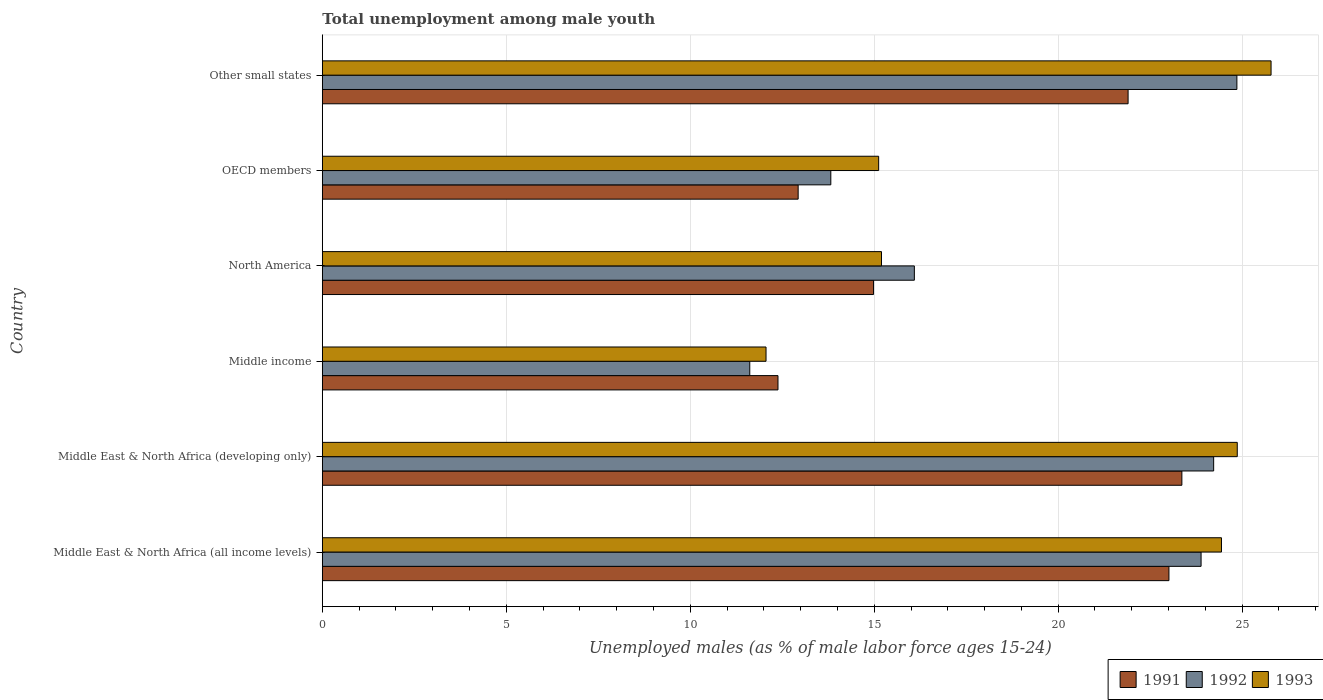Are the number of bars per tick equal to the number of legend labels?
Provide a short and direct response. Yes. Are the number of bars on each tick of the Y-axis equal?
Offer a terse response. Yes. How many bars are there on the 5th tick from the top?
Make the answer very short. 3. How many bars are there on the 1st tick from the bottom?
Provide a succinct answer. 3. What is the label of the 1st group of bars from the top?
Make the answer very short. Other small states. What is the percentage of unemployed males in in 1991 in Middle East & North Africa (developing only)?
Ensure brevity in your answer.  23.36. Across all countries, what is the maximum percentage of unemployed males in in 1993?
Keep it short and to the point. 25.79. Across all countries, what is the minimum percentage of unemployed males in in 1992?
Keep it short and to the point. 11.62. In which country was the percentage of unemployed males in in 1993 maximum?
Give a very brief answer. Other small states. In which country was the percentage of unemployed males in in 1993 minimum?
Give a very brief answer. Middle income. What is the total percentage of unemployed males in in 1991 in the graph?
Provide a short and direct response. 108.57. What is the difference between the percentage of unemployed males in in 1993 in Middle East & North Africa (all income levels) and that in North America?
Your answer should be very brief. 9.24. What is the difference between the percentage of unemployed males in in 1993 in North America and the percentage of unemployed males in in 1992 in Middle East & North Africa (all income levels)?
Keep it short and to the point. -8.69. What is the average percentage of unemployed males in in 1993 per country?
Provide a succinct answer. 19.58. What is the difference between the percentage of unemployed males in in 1991 and percentage of unemployed males in in 1992 in Middle income?
Provide a succinct answer. 0.77. In how many countries, is the percentage of unemployed males in in 1991 greater than 19 %?
Keep it short and to the point. 3. What is the ratio of the percentage of unemployed males in in 1993 in Middle income to that in OECD members?
Give a very brief answer. 0.8. Is the percentage of unemployed males in in 1993 in Middle East & North Africa (developing only) less than that in North America?
Give a very brief answer. No. What is the difference between the highest and the second highest percentage of unemployed males in in 1991?
Your answer should be very brief. 0.35. What is the difference between the highest and the lowest percentage of unemployed males in in 1993?
Provide a short and direct response. 13.73. In how many countries, is the percentage of unemployed males in in 1991 greater than the average percentage of unemployed males in in 1991 taken over all countries?
Ensure brevity in your answer.  3. What does the 2nd bar from the bottom in Other small states represents?
Ensure brevity in your answer.  1992. Are the values on the major ticks of X-axis written in scientific E-notation?
Make the answer very short. No. Does the graph contain grids?
Keep it short and to the point. Yes. Where does the legend appear in the graph?
Your response must be concise. Bottom right. What is the title of the graph?
Provide a short and direct response. Total unemployment among male youth. Does "2001" appear as one of the legend labels in the graph?
Offer a very short reply. No. What is the label or title of the X-axis?
Make the answer very short. Unemployed males (as % of male labor force ages 15-24). What is the label or title of the Y-axis?
Ensure brevity in your answer.  Country. What is the Unemployed males (as % of male labor force ages 15-24) in 1991 in Middle East & North Africa (all income levels)?
Give a very brief answer. 23.01. What is the Unemployed males (as % of male labor force ages 15-24) in 1992 in Middle East & North Africa (all income levels)?
Keep it short and to the point. 23.88. What is the Unemployed males (as % of male labor force ages 15-24) of 1993 in Middle East & North Africa (all income levels)?
Your response must be concise. 24.44. What is the Unemployed males (as % of male labor force ages 15-24) of 1991 in Middle East & North Africa (developing only)?
Provide a succinct answer. 23.36. What is the Unemployed males (as % of male labor force ages 15-24) of 1992 in Middle East & North Africa (developing only)?
Your response must be concise. 24.23. What is the Unemployed males (as % of male labor force ages 15-24) in 1993 in Middle East & North Africa (developing only)?
Your answer should be very brief. 24.87. What is the Unemployed males (as % of male labor force ages 15-24) in 1991 in Middle income?
Offer a terse response. 12.38. What is the Unemployed males (as % of male labor force ages 15-24) of 1992 in Middle income?
Offer a very short reply. 11.62. What is the Unemployed males (as % of male labor force ages 15-24) in 1993 in Middle income?
Your answer should be very brief. 12.06. What is the Unemployed males (as % of male labor force ages 15-24) of 1991 in North America?
Give a very brief answer. 14.98. What is the Unemployed males (as % of male labor force ages 15-24) in 1992 in North America?
Make the answer very short. 16.09. What is the Unemployed males (as % of male labor force ages 15-24) of 1993 in North America?
Make the answer very short. 15.2. What is the Unemployed males (as % of male labor force ages 15-24) in 1991 in OECD members?
Make the answer very short. 12.93. What is the Unemployed males (as % of male labor force ages 15-24) in 1992 in OECD members?
Your answer should be very brief. 13.82. What is the Unemployed males (as % of male labor force ages 15-24) in 1993 in OECD members?
Your answer should be very brief. 15.12. What is the Unemployed males (as % of male labor force ages 15-24) in 1991 in Other small states?
Ensure brevity in your answer.  21.9. What is the Unemployed males (as % of male labor force ages 15-24) of 1992 in Other small states?
Your response must be concise. 24.86. What is the Unemployed males (as % of male labor force ages 15-24) of 1993 in Other small states?
Offer a very short reply. 25.79. Across all countries, what is the maximum Unemployed males (as % of male labor force ages 15-24) of 1991?
Your response must be concise. 23.36. Across all countries, what is the maximum Unemployed males (as % of male labor force ages 15-24) of 1992?
Offer a very short reply. 24.86. Across all countries, what is the maximum Unemployed males (as % of male labor force ages 15-24) in 1993?
Keep it short and to the point. 25.79. Across all countries, what is the minimum Unemployed males (as % of male labor force ages 15-24) in 1991?
Make the answer very short. 12.38. Across all countries, what is the minimum Unemployed males (as % of male labor force ages 15-24) in 1992?
Your answer should be compact. 11.62. Across all countries, what is the minimum Unemployed males (as % of male labor force ages 15-24) of 1993?
Provide a short and direct response. 12.06. What is the total Unemployed males (as % of male labor force ages 15-24) in 1991 in the graph?
Make the answer very short. 108.57. What is the total Unemployed males (as % of male labor force ages 15-24) of 1992 in the graph?
Your response must be concise. 114.49. What is the total Unemployed males (as % of male labor force ages 15-24) of 1993 in the graph?
Ensure brevity in your answer.  117.47. What is the difference between the Unemployed males (as % of male labor force ages 15-24) of 1991 in Middle East & North Africa (all income levels) and that in Middle East & North Africa (developing only)?
Give a very brief answer. -0.35. What is the difference between the Unemployed males (as % of male labor force ages 15-24) in 1992 in Middle East & North Africa (all income levels) and that in Middle East & North Africa (developing only)?
Provide a succinct answer. -0.34. What is the difference between the Unemployed males (as % of male labor force ages 15-24) in 1993 in Middle East & North Africa (all income levels) and that in Middle East & North Africa (developing only)?
Ensure brevity in your answer.  -0.43. What is the difference between the Unemployed males (as % of male labor force ages 15-24) of 1991 in Middle East & North Africa (all income levels) and that in Middle income?
Give a very brief answer. 10.63. What is the difference between the Unemployed males (as % of male labor force ages 15-24) in 1992 in Middle East & North Africa (all income levels) and that in Middle income?
Provide a succinct answer. 12.27. What is the difference between the Unemployed males (as % of male labor force ages 15-24) in 1993 in Middle East & North Africa (all income levels) and that in Middle income?
Make the answer very short. 12.38. What is the difference between the Unemployed males (as % of male labor force ages 15-24) in 1991 in Middle East & North Africa (all income levels) and that in North America?
Provide a short and direct response. 8.03. What is the difference between the Unemployed males (as % of male labor force ages 15-24) of 1992 in Middle East & North Africa (all income levels) and that in North America?
Offer a terse response. 7.79. What is the difference between the Unemployed males (as % of male labor force ages 15-24) of 1993 in Middle East & North Africa (all income levels) and that in North America?
Provide a succinct answer. 9.24. What is the difference between the Unemployed males (as % of male labor force ages 15-24) in 1991 in Middle East & North Africa (all income levels) and that in OECD members?
Keep it short and to the point. 10.08. What is the difference between the Unemployed males (as % of male labor force ages 15-24) of 1992 in Middle East & North Africa (all income levels) and that in OECD members?
Your response must be concise. 10.06. What is the difference between the Unemployed males (as % of male labor force ages 15-24) of 1993 in Middle East & North Africa (all income levels) and that in OECD members?
Your response must be concise. 9.32. What is the difference between the Unemployed males (as % of male labor force ages 15-24) in 1991 in Middle East & North Africa (all income levels) and that in Other small states?
Your response must be concise. 1.11. What is the difference between the Unemployed males (as % of male labor force ages 15-24) in 1992 in Middle East & North Africa (all income levels) and that in Other small states?
Provide a short and direct response. -0.97. What is the difference between the Unemployed males (as % of male labor force ages 15-24) in 1993 in Middle East & North Africa (all income levels) and that in Other small states?
Ensure brevity in your answer.  -1.35. What is the difference between the Unemployed males (as % of male labor force ages 15-24) of 1991 in Middle East & North Africa (developing only) and that in Middle income?
Your answer should be very brief. 10.98. What is the difference between the Unemployed males (as % of male labor force ages 15-24) in 1992 in Middle East & North Africa (developing only) and that in Middle income?
Your answer should be compact. 12.61. What is the difference between the Unemployed males (as % of male labor force ages 15-24) in 1993 in Middle East & North Africa (developing only) and that in Middle income?
Ensure brevity in your answer.  12.81. What is the difference between the Unemployed males (as % of male labor force ages 15-24) of 1991 in Middle East & North Africa (developing only) and that in North America?
Your answer should be compact. 8.38. What is the difference between the Unemployed males (as % of male labor force ages 15-24) in 1992 in Middle East & North Africa (developing only) and that in North America?
Your response must be concise. 8.13. What is the difference between the Unemployed males (as % of male labor force ages 15-24) of 1993 in Middle East & North Africa (developing only) and that in North America?
Your answer should be compact. 9.67. What is the difference between the Unemployed males (as % of male labor force ages 15-24) of 1991 in Middle East & North Africa (developing only) and that in OECD members?
Your answer should be compact. 10.43. What is the difference between the Unemployed males (as % of male labor force ages 15-24) of 1992 in Middle East & North Africa (developing only) and that in OECD members?
Offer a very short reply. 10.41. What is the difference between the Unemployed males (as % of male labor force ages 15-24) in 1993 in Middle East & North Africa (developing only) and that in OECD members?
Offer a terse response. 9.75. What is the difference between the Unemployed males (as % of male labor force ages 15-24) in 1991 in Middle East & North Africa (developing only) and that in Other small states?
Offer a terse response. 1.46. What is the difference between the Unemployed males (as % of male labor force ages 15-24) in 1992 in Middle East & North Africa (developing only) and that in Other small states?
Your response must be concise. -0.63. What is the difference between the Unemployed males (as % of male labor force ages 15-24) of 1993 in Middle East & North Africa (developing only) and that in Other small states?
Keep it short and to the point. -0.92. What is the difference between the Unemployed males (as % of male labor force ages 15-24) of 1991 in Middle income and that in North America?
Provide a short and direct response. -2.6. What is the difference between the Unemployed males (as % of male labor force ages 15-24) in 1992 in Middle income and that in North America?
Ensure brevity in your answer.  -4.47. What is the difference between the Unemployed males (as % of male labor force ages 15-24) in 1993 in Middle income and that in North America?
Make the answer very short. -3.14. What is the difference between the Unemployed males (as % of male labor force ages 15-24) in 1991 in Middle income and that in OECD members?
Offer a very short reply. -0.55. What is the difference between the Unemployed males (as % of male labor force ages 15-24) in 1992 in Middle income and that in OECD members?
Give a very brief answer. -2.2. What is the difference between the Unemployed males (as % of male labor force ages 15-24) in 1993 in Middle income and that in OECD members?
Offer a very short reply. -3.06. What is the difference between the Unemployed males (as % of male labor force ages 15-24) in 1991 in Middle income and that in Other small states?
Your answer should be very brief. -9.52. What is the difference between the Unemployed males (as % of male labor force ages 15-24) in 1992 in Middle income and that in Other small states?
Provide a succinct answer. -13.24. What is the difference between the Unemployed males (as % of male labor force ages 15-24) of 1993 in Middle income and that in Other small states?
Offer a very short reply. -13.73. What is the difference between the Unemployed males (as % of male labor force ages 15-24) in 1991 in North America and that in OECD members?
Provide a succinct answer. 2.05. What is the difference between the Unemployed males (as % of male labor force ages 15-24) of 1992 in North America and that in OECD members?
Make the answer very short. 2.27. What is the difference between the Unemployed males (as % of male labor force ages 15-24) in 1993 in North America and that in OECD members?
Provide a short and direct response. 0.08. What is the difference between the Unemployed males (as % of male labor force ages 15-24) of 1991 in North America and that in Other small states?
Give a very brief answer. -6.92. What is the difference between the Unemployed males (as % of male labor force ages 15-24) in 1992 in North America and that in Other small states?
Your answer should be very brief. -8.77. What is the difference between the Unemployed males (as % of male labor force ages 15-24) of 1993 in North America and that in Other small states?
Offer a terse response. -10.59. What is the difference between the Unemployed males (as % of male labor force ages 15-24) of 1991 in OECD members and that in Other small states?
Your answer should be very brief. -8.97. What is the difference between the Unemployed males (as % of male labor force ages 15-24) in 1992 in OECD members and that in Other small states?
Your answer should be compact. -11.04. What is the difference between the Unemployed males (as % of male labor force ages 15-24) in 1993 in OECD members and that in Other small states?
Your response must be concise. -10.66. What is the difference between the Unemployed males (as % of male labor force ages 15-24) in 1991 in Middle East & North Africa (all income levels) and the Unemployed males (as % of male labor force ages 15-24) in 1992 in Middle East & North Africa (developing only)?
Your answer should be very brief. -1.22. What is the difference between the Unemployed males (as % of male labor force ages 15-24) in 1991 in Middle East & North Africa (all income levels) and the Unemployed males (as % of male labor force ages 15-24) in 1993 in Middle East & North Africa (developing only)?
Give a very brief answer. -1.86. What is the difference between the Unemployed males (as % of male labor force ages 15-24) in 1992 in Middle East & North Africa (all income levels) and the Unemployed males (as % of male labor force ages 15-24) in 1993 in Middle East & North Africa (developing only)?
Ensure brevity in your answer.  -0.98. What is the difference between the Unemployed males (as % of male labor force ages 15-24) of 1991 in Middle East & North Africa (all income levels) and the Unemployed males (as % of male labor force ages 15-24) of 1992 in Middle income?
Provide a succinct answer. 11.39. What is the difference between the Unemployed males (as % of male labor force ages 15-24) of 1991 in Middle East & North Africa (all income levels) and the Unemployed males (as % of male labor force ages 15-24) of 1993 in Middle income?
Your response must be concise. 10.95. What is the difference between the Unemployed males (as % of male labor force ages 15-24) in 1992 in Middle East & North Africa (all income levels) and the Unemployed males (as % of male labor force ages 15-24) in 1993 in Middle income?
Your response must be concise. 11.82. What is the difference between the Unemployed males (as % of male labor force ages 15-24) of 1991 in Middle East & North Africa (all income levels) and the Unemployed males (as % of male labor force ages 15-24) of 1992 in North America?
Your response must be concise. 6.92. What is the difference between the Unemployed males (as % of male labor force ages 15-24) in 1991 in Middle East & North Africa (all income levels) and the Unemployed males (as % of male labor force ages 15-24) in 1993 in North America?
Ensure brevity in your answer.  7.81. What is the difference between the Unemployed males (as % of male labor force ages 15-24) in 1992 in Middle East & North Africa (all income levels) and the Unemployed males (as % of male labor force ages 15-24) in 1993 in North America?
Your response must be concise. 8.69. What is the difference between the Unemployed males (as % of male labor force ages 15-24) in 1991 in Middle East & North Africa (all income levels) and the Unemployed males (as % of male labor force ages 15-24) in 1992 in OECD members?
Offer a very short reply. 9.19. What is the difference between the Unemployed males (as % of male labor force ages 15-24) in 1991 in Middle East & North Africa (all income levels) and the Unemployed males (as % of male labor force ages 15-24) in 1993 in OECD members?
Provide a succinct answer. 7.89. What is the difference between the Unemployed males (as % of male labor force ages 15-24) in 1992 in Middle East & North Africa (all income levels) and the Unemployed males (as % of male labor force ages 15-24) in 1993 in OECD members?
Your response must be concise. 8.76. What is the difference between the Unemployed males (as % of male labor force ages 15-24) of 1991 in Middle East & North Africa (all income levels) and the Unemployed males (as % of male labor force ages 15-24) of 1992 in Other small states?
Your response must be concise. -1.85. What is the difference between the Unemployed males (as % of male labor force ages 15-24) in 1991 in Middle East & North Africa (all income levels) and the Unemployed males (as % of male labor force ages 15-24) in 1993 in Other small states?
Keep it short and to the point. -2.78. What is the difference between the Unemployed males (as % of male labor force ages 15-24) of 1992 in Middle East & North Africa (all income levels) and the Unemployed males (as % of male labor force ages 15-24) of 1993 in Other small states?
Make the answer very short. -1.9. What is the difference between the Unemployed males (as % of male labor force ages 15-24) of 1991 in Middle East & North Africa (developing only) and the Unemployed males (as % of male labor force ages 15-24) of 1992 in Middle income?
Offer a very short reply. 11.74. What is the difference between the Unemployed males (as % of male labor force ages 15-24) of 1991 in Middle East & North Africa (developing only) and the Unemployed males (as % of male labor force ages 15-24) of 1993 in Middle income?
Your answer should be very brief. 11.3. What is the difference between the Unemployed males (as % of male labor force ages 15-24) of 1992 in Middle East & North Africa (developing only) and the Unemployed males (as % of male labor force ages 15-24) of 1993 in Middle income?
Provide a short and direct response. 12.17. What is the difference between the Unemployed males (as % of male labor force ages 15-24) in 1991 in Middle East & North Africa (developing only) and the Unemployed males (as % of male labor force ages 15-24) in 1992 in North America?
Your answer should be very brief. 7.27. What is the difference between the Unemployed males (as % of male labor force ages 15-24) in 1991 in Middle East & North Africa (developing only) and the Unemployed males (as % of male labor force ages 15-24) in 1993 in North America?
Provide a succinct answer. 8.16. What is the difference between the Unemployed males (as % of male labor force ages 15-24) in 1992 in Middle East & North Africa (developing only) and the Unemployed males (as % of male labor force ages 15-24) in 1993 in North America?
Your answer should be very brief. 9.03. What is the difference between the Unemployed males (as % of male labor force ages 15-24) in 1991 in Middle East & North Africa (developing only) and the Unemployed males (as % of male labor force ages 15-24) in 1992 in OECD members?
Your response must be concise. 9.54. What is the difference between the Unemployed males (as % of male labor force ages 15-24) of 1991 in Middle East & North Africa (developing only) and the Unemployed males (as % of male labor force ages 15-24) of 1993 in OECD members?
Make the answer very short. 8.24. What is the difference between the Unemployed males (as % of male labor force ages 15-24) of 1992 in Middle East & North Africa (developing only) and the Unemployed males (as % of male labor force ages 15-24) of 1993 in OECD members?
Provide a succinct answer. 9.1. What is the difference between the Unemployed males (as % of male labor force ages 15-24) of 1991 in Middle East & North Africa (developing only) and the Unemployed males (as % of male labor force ages 15-24) of 1992 in Other small states?
Your response must be concise. -1.5. What is the difference between the Unemployed males (as % of male labor force ages 15-24) of 1991 in Middle East & North Africa (developing only) and the Unemployed males (as % of male labor force ages 15-24) of 1993 in Other small states?
Offer a very short reply. -2.42. What is the difference between the Unemployed males (as % of male labor force ages 15-24) of 1992 in Middle East & North Africa (developing only) and the Unemployed males (as % of male labor force ages 15-24) of 1993 in Other small states?
Your answer should be compact. -1.56. What is the difference between the Unemployed males (as % of male labor force ages 15-24) of 1991 in Middle income and the Unemployed males (as % of male labor force ages 15-24) of 1992 in North America?
Ensure brevity in your answer.  -3.71. What is the difference between the Unemployed males (as % of male labor force ages 15-24) of 1991 in Middle income and the Unemployed males (as % of male labor force ages 15-24) of 1993 in North America?
Offer a very short reply. -2.81. What is the difference between the Unemployed males (as % of male labor force ages 15-24) in 1992 in Middle income and the Unemployed males (as % of male labor force ages 15-24) in 1993 in North America?
Offer a terse response. -3.58. What is the difference between the Unemployed males (as % of male labor force ages 15-24) of 1991 in Middle income and the Unemployed males (as % of male labor force ages 15-24) of 1992 in OECD members?
Provide a succinct answer. -1.44. What is the difference between the Unemployed males (as % of male labor force ages 15-24) of 1991 in Middle income and the Unemployed males (as % of male labor force ages 15-24) of 1993 in OECD members?
Make the answer very short. -2.74. What is the difference between the Unemployed males (as % of male labor force ages 15-24) in 1992 in Middle income and the Unemployed males (as % of male labor force ages 15-24) in 1993 in OECD members?
Your answer should be compact. -3.5. What is the difference between the Unemployed males (as % of male labor force ages 15-24) in 1991 in Middle income and the Unemployed males (as % of male labor force ages 15-24) in 1992 in Other small states?
Keep it short and to the point. -12.47. What is the difference between the Unemployed males (as % of male labor force ages 15-24) of 1991 in Middle income and the Unemployed males (as % of male labor force ages 15-24) of 1993 in Other small states?
Offer a very short reply. -13.4. What is the difference between the Unemployed males (as % of male labor force ages 15-24) of 1992 in Middle income and the Unemployed males (as % of male labor force ages 15-24) of 1993 in Other small states?
Offer a very short reply. -14.17. What is the difference between the Unemployed males (as % of male labor force ages 15-24) in 1991 in North America and the Unemployed males (as % of male labor force ages 15-24) in 1992 in OECD members?
Ensure brevity in your answer.  1.16. What is the difference between the Unemployed males (as % of male labor force ages 15-24) of 1991 in North America and the Unemployed males (as % of male labor force ages 15-24) of 1993 in OECD members?
Your response must be concise. -0.14. What is the difference between the Unemployed males (as % of male labor force ages 15-24) in 1992 in North America and the Unemployed males (as % of male labor force ages 15-24) in 1993 in OECD members?
Provide a short and direct response. 0.97. What is the difference between the Unemployed males (as % of male labor force ages 15-24) of 1991 in North America and the Unemployed males (as % of male labor force ages 15-24) of 1992 in Other small states?
Provide a succinct answer. -9.88. What is the difference between the Unemployed males (as % of male labor force ages 15-24) of 1991 in North America and the Unemployed males (as % of male labor force ages 15-24) of 1993 in Other small states?
Provide a succinct answer. -10.8. What is the difference between the Unemployed males (as % of male labor force ages 15-24) in 1992 in North America and the Unemployed males (as % of male labor force ages 15-24) in 1993 in Other small states?
Your response must be concise. -9.69. What is the difference between the Unemployed males (as % of male labor force ages 15-24) in 1991 in OECD members and the Unemployed males (as % of male labor force ages 15-24) in 1992 in Other small states?
Offer a terse response. -11.92. What is the difference between the Unemployed males (as % of male labor force ages 15-24) of 1991 in OECD members and the Unemployed males (as % of male labor force ages 15-24) of 1993 in Other small states?
Your answer should be compact. -12.85. What is the difference between the Unemployed males (as % of male labor force ages 15-24) of 1992 in OECD members and the Unemployed males (as % of male labor force ages 15-24) of 1993 in Other small states?
Your answer should be very brief. -11.97. What is the average Unemployed males (as % of male labor force ages 15-24) of 1991 per country?
Provide a succinct answer. 18.09. What is the average Unemployed males (as % of male labor force ages 15-24) of 1992 per country?
Your response must be concise. 19.08. What is the average Unemployed males (as % of male labor force ages 15-24) of 1993 per country?
Make the answer very short. 19.58. What is the difference between the Unemployed males (as % of male labor force ages 15-24) in 1991 and Unemployed males (as % of male labor force ages 15-24) in 1992 in Middle East & North Africa (all income levels)?
Offer a very short reply. -0.87. What is the difference between the Unemployed males (as % of male labor force ages 15-24) in 1991 and Unemployed males (as % of male labor force ages 15-24) in 1993 in Middle East & North Africa (all income levels)?
Your answer should be compact. -1.43. What is the difference between the Unemployed males (as % of male labor force ages 15-24) of 1992 and Unemployed males (as % of male labor force ages 15-24) of 1993 in Middle East & North Africa (all income levels)?
Your answer should be compact. -0.55. What is the difference between the Unemployed males (as % of male labor force ages 15-24) in 1991 and Unemployed males (as % of male labor force ages 15-24) in 1992 in Middle East & North Africa (developing only)?
Keep it short and to the point. -0.86. What is the difference between the Unemployed males (as % of male labor force ages 15-24) of 1991 and Unemployed males (as % of male labor force ages 15-24) of 1993 in Middle East & North Africa (developing only)?
Ensure brevity in your answer.  -1.51. What is the difference between the Unemployed males (as % of male labor force ages 15-24) in 1992 and Unemployed males (as % of male labor force ages 15-24) in 1993 in Middle East & North Africa (developing only)?
Give a very brief answer. -0.64. What is the difference between the Unemployed males (as % of male labor force ages 15-24) of 1991 and Unemployed males (as % of male labor force ages 15-24) of 1992 in Middle income?
Your response must be concise. 0.77. What is the difference between the Unemployed males (as % of male labor force ages 15-24) in 1991 and Unemployed males (as % of male labor force ages 15-24) in 1993 in Middle income?
Your answer should be compact. 0.32. What is the difference between the Unemployed males (as % of male labor force ages 15-24) in 1992 and Unemployed males (as % of male labor force ages 15-24) in 1993 in Middle income?
Ensure brevity in your answer.  -0.44. What is the difference between the Unemployed males (as % of male labor force ages 15-24) of 1991 and Unemployed males (as % of male labor force ages 15-24) of 1992 in North America?
Your answer should be compact. -1.11. What is the difference between the Unemployed males (as % of male labor force ages 15-24) of 1991 and Unemployed males (as % of male labor force ages 15-24) of 1993 in North America?
Give a very brief answer. -0.22. What is the difference between the Unemployed males (as % of male labor force ages 15-24) in 1992 and Unemployed males (as % of male labor force ages 15-24) in 1993 in North America?
Provide a succinct answer. 0.89. What is the difference between the Unemployed males (as % of male labor force ages 15-24) of 1991 and Unemployed males (as % of male labor force ages 15-24) of 1992 in OECD members?
Make the answer very short. -0.89. What is the difference between the Unemployed males (as % of male labor force ages 15-24) in 1991 and Unemployed males (as % of male labor force ages 15-24) in 1993 in OECD members?
Your answer should be very brief. -2.19. What is the difference between the Unemployed males (as % of male labor force ages 15-24) of 1992 and Unemployed males (as % of male labor force ages 15-24) of 1993 in OECD members?
Give a very brief answer. -1.3. What is the difference between the Unemployed males (as % of male labor force ages 15-24) in 1991 and Unemployed males (as % of male labor force ages 15-24) in 1992 in Other small states?
Give a very brief answer. -2.96. What is the difference between the Unemployed males (as % of male labor force ages 15-24) in 1991 and Unemployed males (as % of male labor force ages 15-24) in 1993 in Other small states?
Keep it short and to the point. -3.89. What is the difference between the Unemployed males (as % of male labor force ages 15-24) in 1992 and Unemployed males (as % of male labor force ages 15-24) in 1993 in Other small states?
Your answer should be very brief. -0.93. What is the ratio of the Unemployed males (as % of male labor force ages 15-24) of 1991 in Middle East & North Africa (all income levels) to that in Middle East & North Africa (developing only)?
Offer a very short reply. 0.98. What is the ratio of the Unemployed males (as % of male labor force ages 15-24) in 1992 in Middle East & North Africa (all income levels) to that in Middle East & North Africa (developing only)?
Your answer should be compact. 0.99. What is the ratio of the Unemployed males (as % of male labor force ages 15-24) in 1993 in Middle East & North Africa (all income levels) to that in Middle East & North Africa (developing only)?
Your answer should be compact. 0.98. What is the ratio of the Unemployed males (as % of male labor force ages 15-24) in 1991 in Middle East & North Africa (all income levels) to that in Middle income?
Your response must be concise. 1.86. What is the ratio of the Unemployed males (as % of male labor force ages 15-24) in 1992 in Middle East & North Africa (all income levels) to that in Middle income?
Provide a short and direct response. 2.06. What is the ratio of the Unemployed males (as % of male labor force ages 15-24) of 1993 in Middle East & North Africa (all income levels) to that in Middle income?
Offer a terse response. 2.03. What is the ratio of the Unemployed males (as % of male labor force ages 15-24) in 1991 in Middle East & North Africa (all income levels) to that in North America?
Your answer should be very brief. 1.54. What is the ratio of the Unemployed males (as % of male labor force ages 15-24) of 1992 in Middle East & North Africa (all income levels) to that in North America?
Your response must be concise. 1.48. What is the ratio of the Unemployed males (as % of male labor force ages 15-24) of 1993 in Middle East & North Africa (all income levels) to that in North America?
Your answer should be compact. 1.61. What is the ratio of the Unemployed males (as % of male labor force ages 15-24) in 1991 in Middle East & North Africa (all income levels) to that in OECD members?
Give a very brief answer. 1.78. What is the ratio of the Unemployed males (as % of male labor force ages 15-24) in 1992 in Middle East & North Africa (all income levels) to that in OECD members?
Provide a succinct answer. 1.73. What is the ratio of the Unemployed males (as % of male labor force ages 15-24) in 1993 in Middle East & North Africa (all income levels) to that in OECD members?
Offer a very short reply. 1.62. What is the ratio of the Unemployed males (as % of male labor force ages 15-24) in 1991 in Middle East & North Africa (all income levels) to that in Other small states?
Keep it short and to the point. 1.05. What is the ratio of the Unemployed males (as % of male labor force ages 15-24) of 1992 in Middle East & North Africa (all income levels) to that in Other small states?
Your response must be concise. 0.96. What is the ratio of the Unemployed males (as % of male labor force ages 15-24) of 1993 in Middle East & North Africa (all income levels) to that in Other small states?
Offer a very short reply. 0.95. What is the ratio of the Unemployed males (as % of male labor force ages 15-24) in 1991 in Middle East & North Africa (developing only) to that in Middle income?
Offer a very short reply. 1.89. What is the ratio of the Unemployed males (as % of male labor force ages 15-24) in 1992 in Middle East & North Africa (developing only) to that in Middle income?
Make the answer very short. 2.09. What is the ratio of the Unemployed males (as % of male labor force ages 15-24) of 1993 in Middle East & North Africa (developing only) to that in Middle income?
Your answer should be very brief. 2.06. What is the ratio of the Unemployed males (as % of male labor force ages 15-24) of 1991 in Middle East & North Africa (developing only) to that in North America?
Your answer should be very brief. 1.56. What is the ratio of the Unemployed males (as % of male labor force ages 15-24) in 1992 in Middle East & North Africa (developing only) to that in North America?
Ensure brevity in your answer.  1.51. What is the ratio of the Unemployed males (as % of male labor force ages 15-24) of 1993 in Middle East & North Africa (developing only) to that in North America?
Offer a terse response. 1.64. What is the ratio of the Unemployed males (as % of male labor force ages 15-24) in 1991 in Middle East & North Africa (developing only) to that in OECD members?
Keep it short and to the point. 1.81. What is the ratio of the Unemployed males (as % of male labor force ages 15-24) of 1992 in Middle East & North Africa (developing only) to that in OECD members?
Make the answer very short. 1.75. What is the ratio of the Unemployed males (as % of male labor force ages 15-24) in 1993 in Middle East & North Africa (developing only) to that in OECD members?
Your answer should be compact. 1.64. What is the ratio of the Unemployed males (as % of male labor force ages 15-24) of 1991 in Middle East & North Africa (developing only) to that in Other small states?
Give a very brief answer. 1.07. What is the ratio of the Unemployed males (as % of male labor force ages 15-24) of 1992 in Middle East & North Africa (developing only) to that in Other small states?
Offer a very short reply. 0.97. What is the ratio of the Unemployed males (as % of male labor force ages 15-24) of 1993 in Middle East & North Africa (developing only) to that in Other small states?
Your answer should be very brief. 0.96. What is the ratio of the Unemployed males (as % of male labor force ages 15-24) of 1991 in Middle income to that in North America?
Offer a terse response. 0.83. What is the ratio of the Unemployed males (as % of male labor force ages 15-24) of 1992 in Middle income to that in North America?
Ensure brevity in your answer.  0.72. What is the ratio of the Unemployed males (as % of male labor force ages 15-24) of 1993 in Middle income to that in North America?
Your response must be concise. 0.79. What is the ratio of the Unemployed males (as % of male labor force ages 15-24) of 1991 in Middle income to that in OECD members?
Make the answer very short. 0.96. What is the ratio of the Unemployed males (as % of male labor force ages 15-24) in 1992 in Middle income to that in OECD members?
Provide a succinct answer. 0.84. What is the ratio of the Unemployed males (as % of male labor force ages 15-24) in 1993 in Middle income to that in OECD members?
Offer a very short reply. 0.8. What is the ratio of the Unemployed males (as % of male labor force ages 15-24) in 1991 in Middle income to that in Other small states?
Give a very brief answer. 0.57. What is the ratio of the Unemployed males (as % of male labor force ages 15-24) in 1992 in Middle income to that in Other small states?
Provide a succinct answer. 0.47. What is the ratio of the Unemployed males (as % of male labor force ages 15-24) of 1993 in Middle income to that in Other small states?
Give a very brief answer. 0.47. What is the ratio of the Unemployed males (as % of male labor force ages 15-24) of 1991 in North America to that in OECD members?
Your answer should be very brief. 1.16. What is the ratio of the Unemployed males (as % of male labor force ages 15-24) of 1992 in North America to that in OECD members?
Provide a short and direct response. 1.16. What is the ratio of the Unemployed males (as % of male labor force ages 15-24) of 1993 in North America to that in OECD members?
Provide a short and direct response. 1.01. What is the ratio of the Unemployed males (as % of male labor force ages 15-24) of 1991 in North America to that in Other small states?
Give a very brief answer. 0.68. What is the ratio of the Unemployed males (as % of male labor force ages 15-24) of 1992 in North America to that in Other small states?
Offer a very short reply. 0.65. What is the ratio of the Unemployed males (as % of male labor force ages 15-24) of 1993 in North America to that in Other small states?
Ensure brevity in your answer.  0.59. What is the ratio of the Unemployed males (as % of male labor force ages 15-24) of 1991 in OECD members to that in Other small states?
Offer a very short reply. 0.59. What is the ratio of the Unemployed males (as % of male labor force ages 15-24) in 1992 in OECD members to that in Other small states?
Give a very brief answer. 0.56. What is the ratio of the Unemployed males (as % of male labor force ages 15-24) of 1993 in OECD members to that in Other small states?
Ensure brevity in your answer.  0.59. What is the difference between the highest and the second highest Unemployed males (as % of male labor force ages 15-24) of 1991?
Offer a terse response. 0.35. What is the difference between the highest and the second highest Unemployed males (as % of male labor force ages 15-24) in 1992?
Keep it short and to the point. 0.63. What is the difference between the highest and the second highest Unemployed males (as % of male labor force ages 15-24) of 1993?
Keep it short and to the point. 0.92. What is the difference between the highest and the lowest Unemployed males (as % of male labor force ages 15-24) of 1991?
Keep it short and to the point. 10.98. What is the difference between the highest and the lowest Unemployed males (as % of male labor force ages 15-24) of 1992?
Make the answer very short. 13.24. What is the difference between the highest and the lowest Unemployed males (as % of male labor force ages 15-24) of 1993?
Provide a short and direct response. 13.73. 